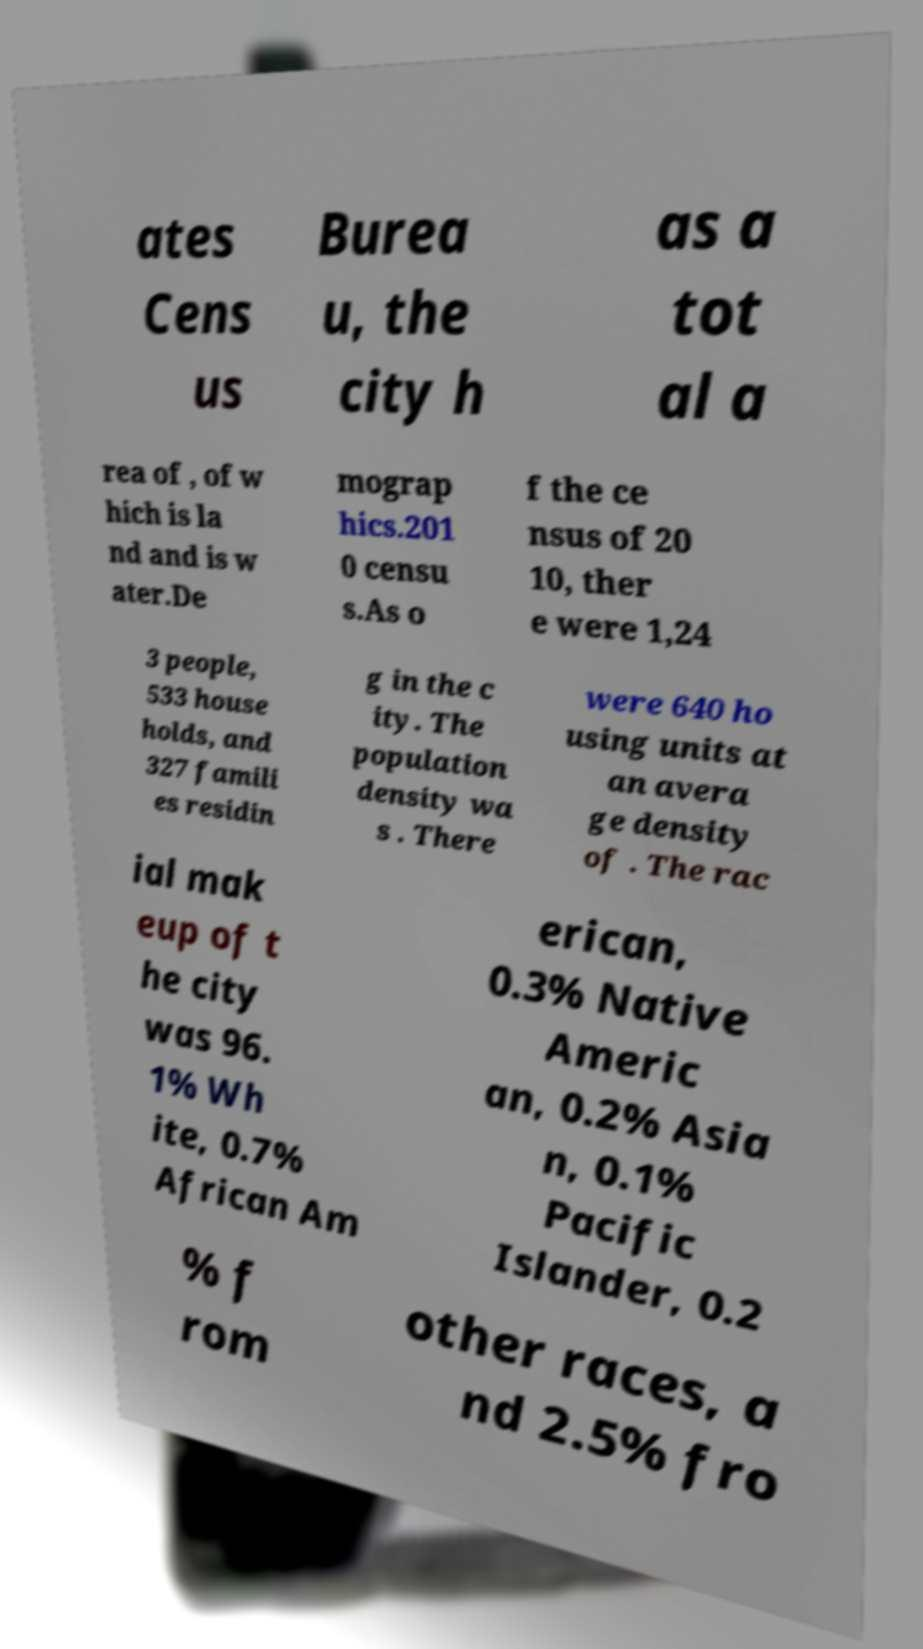I need the written content from this picture converted into text. Can you do that? ates Cens us Burea u, the city h as a tot al a rea of , of w hich is la nd and is w ater.De mograp hics.201 0 censu s.As o f the ce nsus of 20 10, ther e were 1,24 3 people, 533 house holds, and 327 famili es residin g in the c ity. The population density wa s . There were 640 ho using units at an avera ge density of . The rac ial mak eup of t he city was 96. 1% Wh ite, 0.7% African Am erican, 0.3% Native Americ an, 0.2% Asia n, 0.1% Pacific Islander, 0.2 % f rom other races, a nd 2.5% fro 